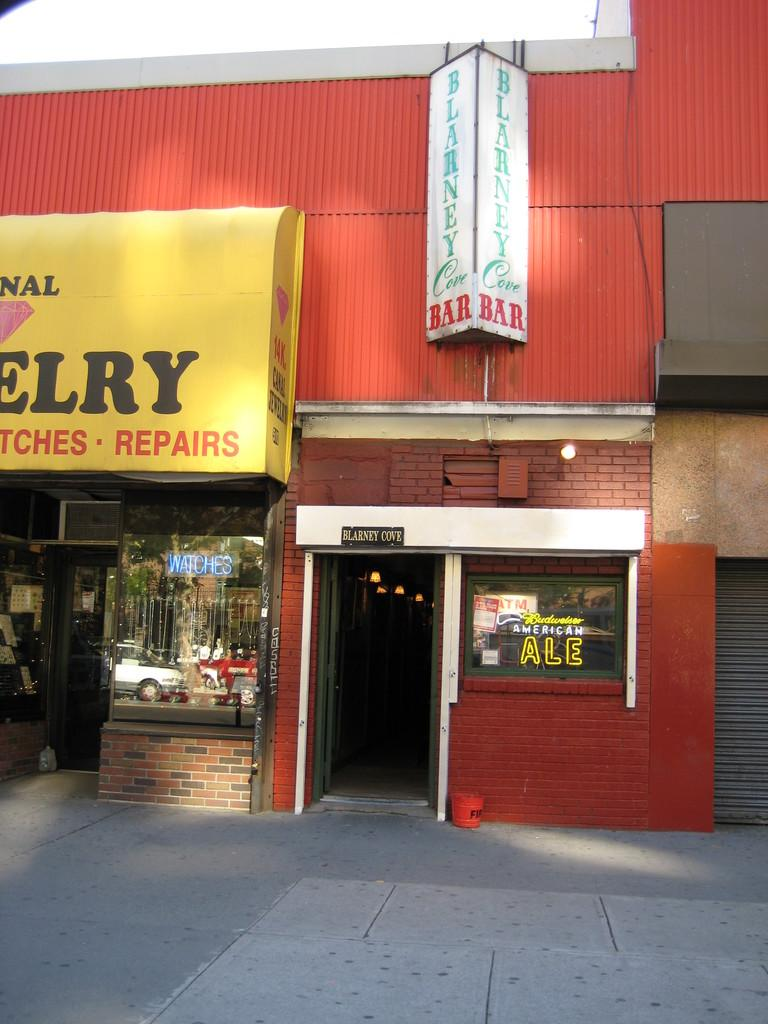What is the main structure in the center of the image? There is a building with stores in the center of the image. What can be seen on the board in the image? There is a board with some text in the image. What is visible at the bottom of the image? There is a floor visible at the bottom of the image. What is visible at the top of the image? There is sky visible at the top of the image. What type of instrument is being played on the dock in the image? There is no dock or instrument present in the image. What is the earth like in the image? The image does not provide information about the earth; it focuses on a building with stores, a board with text, a floor, and the sky. 